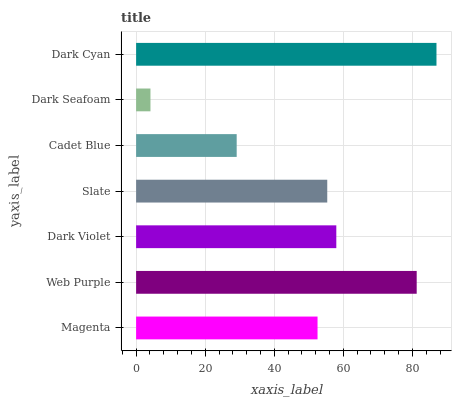Is Dark Seafoam the minimum?
Answer yes or no. Yes. Is Dark Cyan the maximum?
Answer yes or no. Yes. Is Web Purple the minimum?
Answer yes or no. No. Is Web Purple the maximum?
Answer yes or no. No. Is Web Purple greater than Magenta?
Answer yes or no. Yes. Is Magenta less than Web Purple?
Answer yes or no. Yes. Is Magenta greater than Web Purple?
Answer yes or no. No. Is Web Purple less than Magenta?
Answer yes or no. No. Is Slate the high median?
Answer yes or no. Yes. Is Slate the low median?
Answer yes or no. Yes. Is Magenta the high median?
Answer yes or no. No. Is Dark Seafoam the low median?
Answer yes or no. No. 